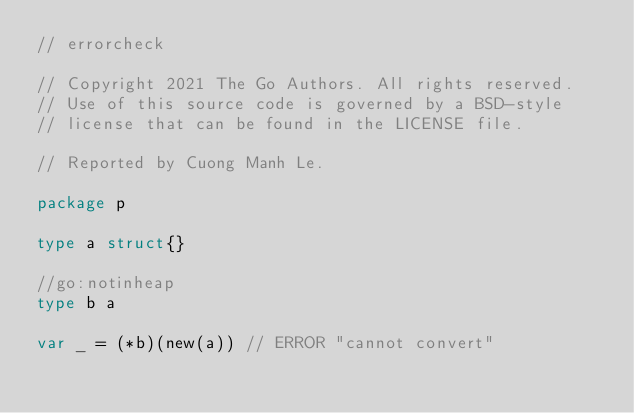<code> <loc_0><loc_0><loc_500><loc_500><_Go_>// errorcheck

// Copyright 2021 The Go Authors. All rights reserved.
// Use of this source code is governed by a BSD-style
// license that can be found in the LICENSE file.

// Reported by Cuong Manh Le.

package p

type a struct{}

//go:notinheap
type b a

var _ = (*b)(new(a)) // ERROR "cannot convert"
</code> 